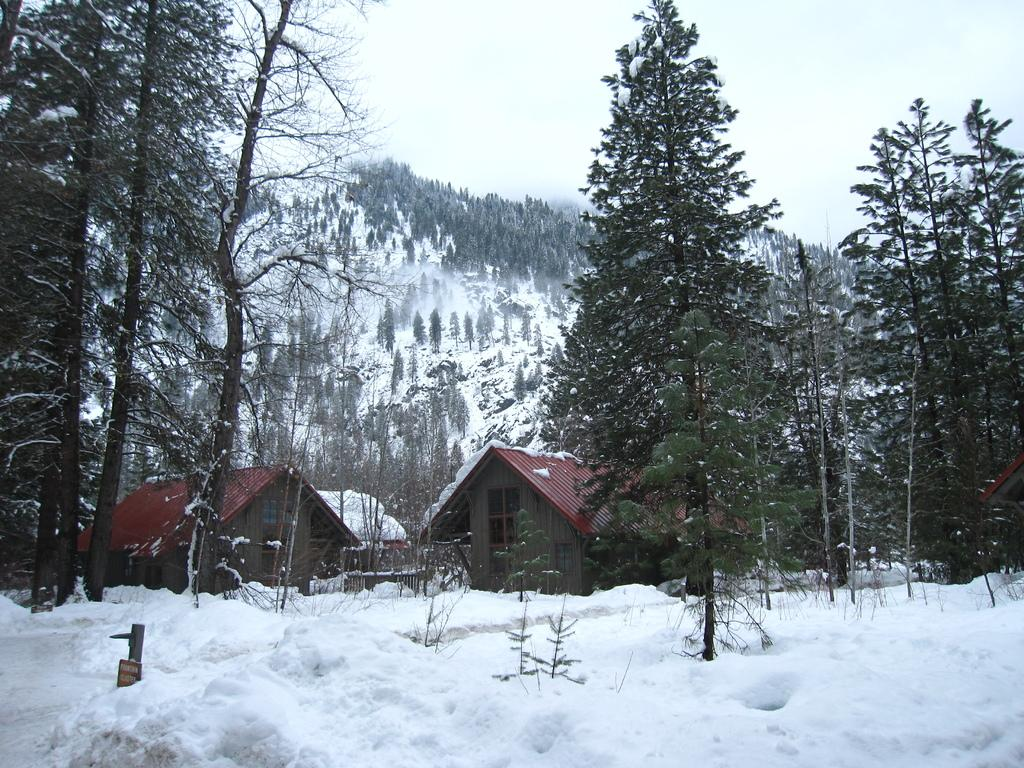What type of weather condition is depicted in the image? There is snow in the image, indicating a cold or snowy weather condition. What type of vegetation can be seen in the image? There are trees and houseplants visible in the image. What architectural features can be seen in the image? There are windows visible in the image. What type of landscape is visible in the image? There are mountains in the image, suggesting a mountainous area. What part of the natural environment is visible in the image? The sky is visible in the image. How many girls are playing in harmony with the mountains in the image? There are no girls present in the image, and the concept of harmony is not applicable to the image. 